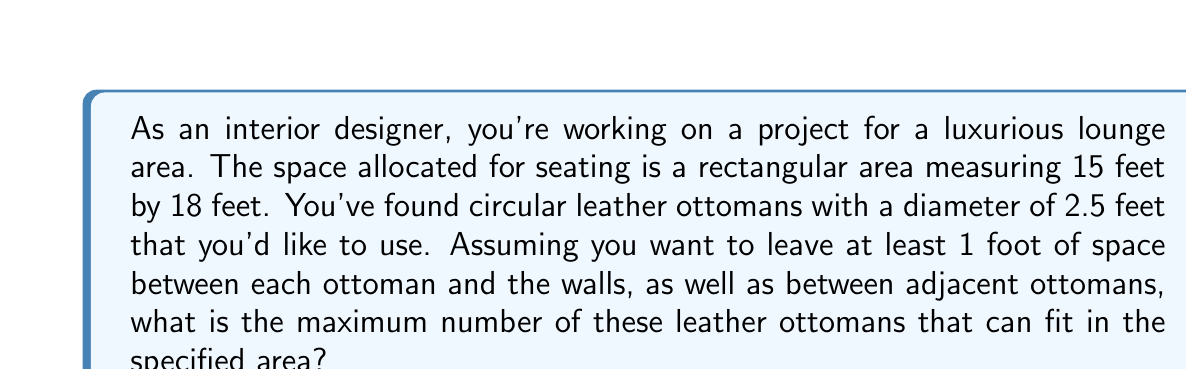Solve this math problem. To solve this problem, we need to follow these steps:

1. Calculate the usable area:
   - Subtract 2 feet from each dimension to account for the 1-foot space around the edges
   - Usable width: $15 - 2 = 13$ feet
   - Usable length: $18 - 2 = 16$ feet

2. Calculate the space needed for each ottoman:
   - Diameter of ottoman: 2.5 feet
   - Space between ottomans: 1 foot
   - Total space per ottoman: $2.5 + 1 = 3.5$ feet

3. Calculate the number of ottomans that can fit in each dimension:
   - Width: $\lfloor \frac{13}{3.5} \rfloor = 3$ ottomans
   - Length: $\lfloor \frac{16}{3.5} \rfloor = 4$ ottomans

   Note: We use the floor function $\lfloor \rfloor$ to round down to the nearest integer.

4. Calculate the total number of ottomans:
   - Maximum number of ottomans = $3 \times 4 = 12$

Therefore, the maximum number of leather ottomans that can fit in the specified area, given the constraints, is 12.

[asy]
unitsize(15);
draw((0,0)--(18,0)--(18,15)--(0,15)--cycle);
for(int i=0; i<4; ++i) {
  for(int j=0; j<3; ++j) {
    draw(circle((2+i*3.5,2+j*3.5),1.25));
  }
}
label("18 ft", (9,-0.5));
label("15 ft", (18.5,7.5), E);
[/asy]
Answer: The maximum number of leather ottomans that can fit in the specified area is 12. 